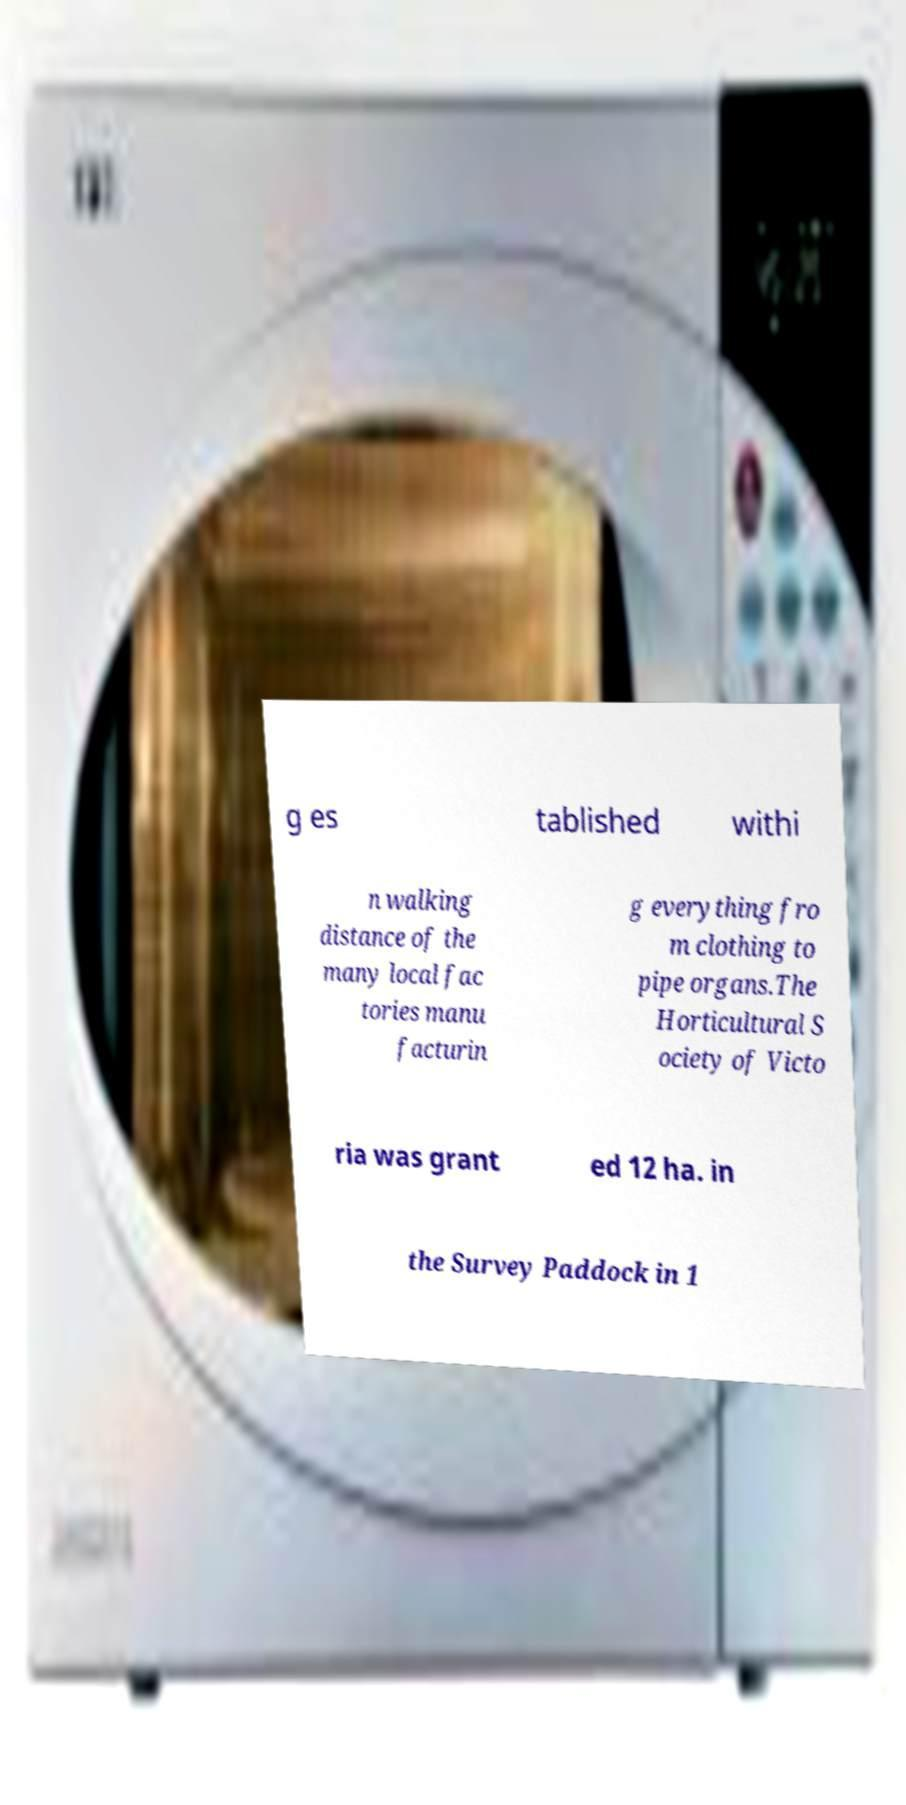Please read and relay the text visible in this image. What does it say? g es tablished withi n walking distance of the many local fac tories manu facturin g everything fro m clothing to pipe organs.The Horticultural S ociety of Victo ria was grant ed 12 ha. in the Survey Paddock in 1 